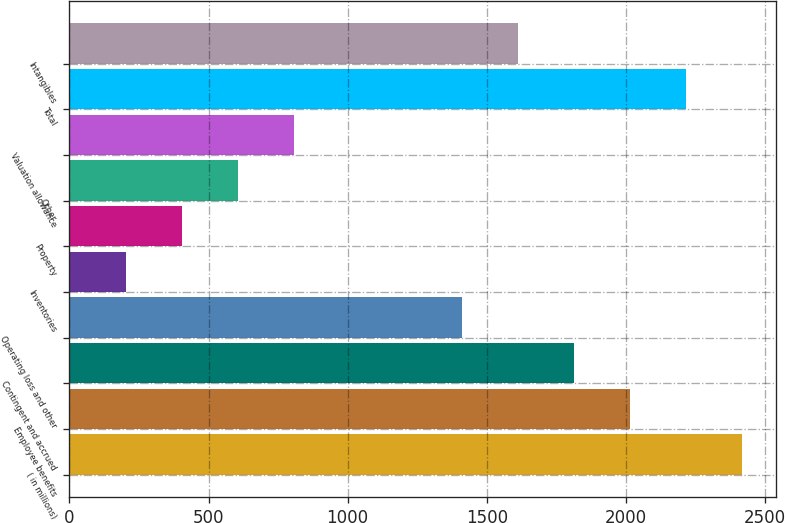<chart> <loc_0><loc_0><loc_500><loc_500><bar_chart><fcel>( in millions)<fcel>Employee benefits<fcel>Contingent and accrued<fcel>Operating loss and other<fcel>Inventories<fcel>Property<fcel>Other<fcel>Valuation allowance<fcel>Total<fcel>Intangibles<nl><fcel>2417.2<fcel>2015<fcel>1813.9<fcel>1411.7<fcel>205.1<fcel>406.2<fcel>607.3<fcel>808.4<fcel>2216.1<fcel>1612.8<nl></chart> 